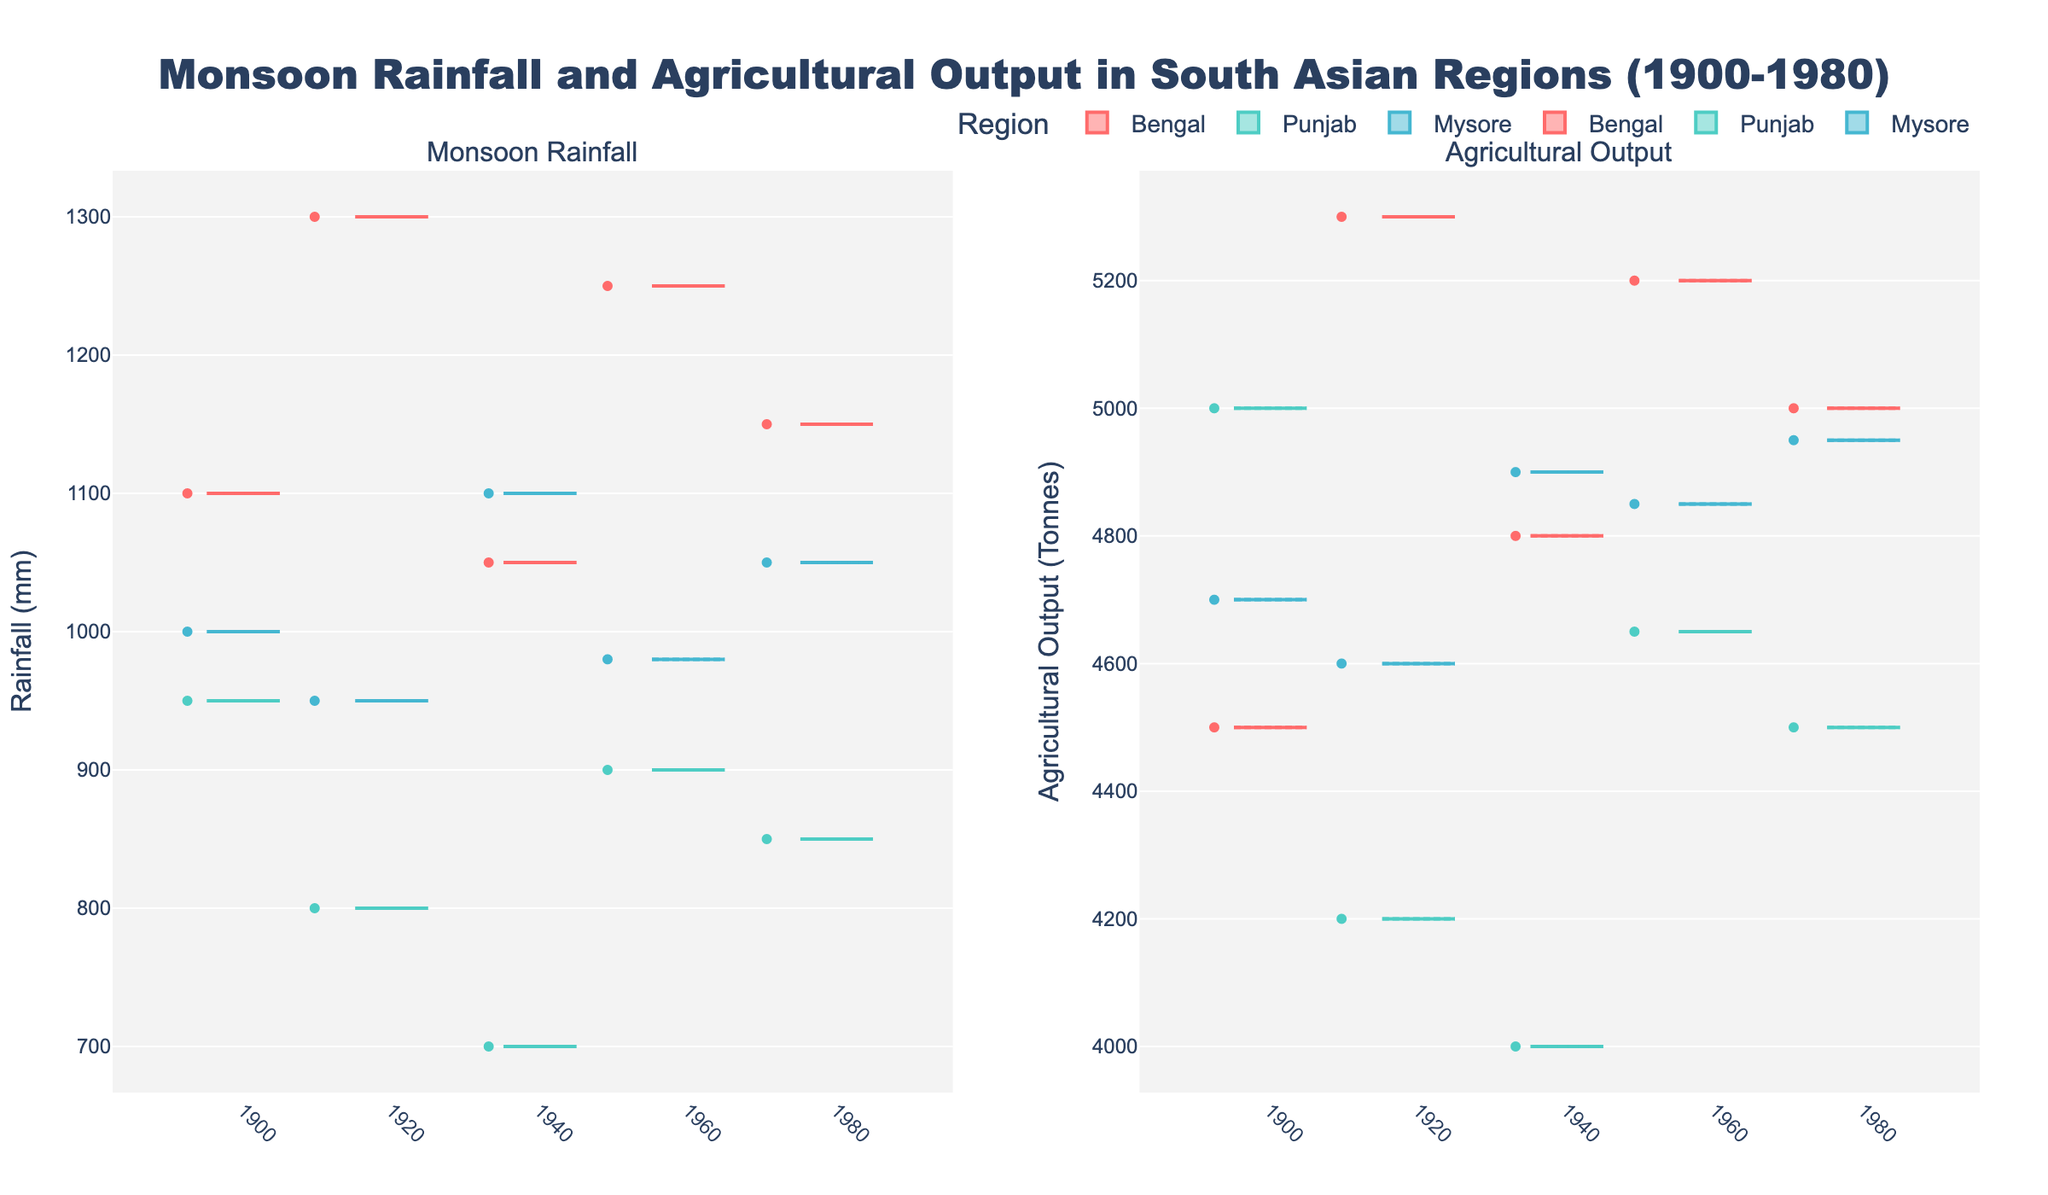What is the title of the plot? The title is located at the top of the plot, displayed in bold text. It typically gives an overall description of the data being visualized. In this case, it reads "Monsoon Rainfall and Agricultural Output in South Asian Regions (1900-1980)."
Answer: Monsoon Rainfall and Agricultural Output in South Asian Regions (1900-1980) What are the two main aspects being compared in the figure? The subplot titles indicate the two main aspects being compared. The left subplot title is "Monsoon Rainfall," and the right subplot title is "Agricultural Output."
Answer: Monsoon Rainfall and Agricultural Output What is the color associated with the Bengal region? Each region is represented by a different color in the notched box plot. By observing the legend or the colors of the boxes, we can identify the region-color association. For Bengal, the color is identified as a reddish hue.
Answer: Reddish For the year 1920, which region has the highest median monsoon rainfall? Look at the notched box plots for 1920. The median is identified by the line inside each box. By comparing the height of the median lines in the respective regions' boxes, Bengal has the highest median.
Answer: Bengal Which region shows the lowest agricultural output in 1920? Examine the right subplot for 1920. The median line within the box plot would give the central tendency. Punjab has the lowest median agricultural output in this year.
Answer: Punjab In which year did Bengal experience the highest variability in monsoon rainfall? Variability can be inferred from the length of the whiskers and the spread of the boxes. The year with the longest box and whiskers for Bengal in the left subplot represents the highest variability. That year is 1920.
Answer: 1920 Compare the median agricultural outputs of Punjab and Mysore in 1960. Which one is higher? The median values are represented by the lines within the boxes. For 1960 in the right subplot, compare the median lines of Punjab and Mysore. Mysore's median line is higher than Punjab's.
Answer: Mysore How did the median monsoon rainfall for Punjab change from 1900 to 1980? By examining the median line within Punjab's boxes in the left subplot for the years 1900 and 1980, one can compare the changes. The median rainfall for Punjab decreased from 1900 to 1980.
Answer: Decreased Across all years, which region shows the most consistent monsoon rainfall? Consistency can be inferred from smaller boxes and shorter whiskers, indicating less variability. By comparing the boxes in the left subplot, Mysore has the most consistently sized boxes across all years.
Answer: Mysore What can we infer about the relationship between higher monsoon rainfall and agricultural output in Bengal? By observing trends across both subplots for Bengal, note if years with higher median rainfall correspond to higher median agricultural output. For Bengal, years with higher median rainfall such as 1920 and 1960, generally also show higher median agricultural outputs.
Answer: Positive correlation 